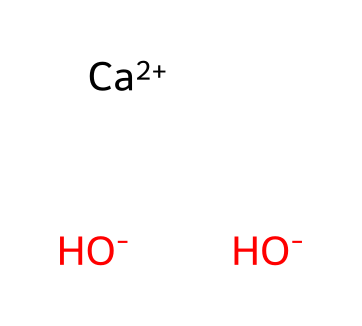What is the name of this chemical? The chemical represented here is calcium hydroxide, which is identified from the presence of the calcium ion (Ca++) and two hydroxide ions (OH-).
Answer: calcium hydroxide How many hydroxide ions are present? The chemical structure shows two hydroxide ions (OH-) indicated by the two OH groups, which are part of the molecular formula.
Answer: two What is the charge of the calcium ion? The calcium ion in the chemical structure has a charge of +2, as indicated by the notation Ca++.
Answer: +2 What type of compound is calcium hydroxide categorized as? Calcium hydroxide contains hydroxide ions, making it a base, which is characteristic of compounds that can accept protons in solution.
Answer: base How many atoms are in the chemical structure? The structure consists of one calcium atom, two oxygen atoms (from the hydroxide ions), and two hydrogen atoms (also from the hydroxide ions), totaling five atoms.
Answer: five How does calcium hydroxide behave in water? Calcium hydroxide dissociates in water to give hydroxide ions (OH-), leading to a basic solution due to the increase in hydroxide concentration.
Answer: basic solution Why is calcium hydroxide commonly used in food preservation? Calcium hydroxide is used in food preservation due to its ability to create an alkaline environment, which can inhibit the growth of certain bacteria during pickling.
Answer: inhibits bacteria 